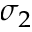<formula> <loc_0><loc_0><loc_500><loc_500>\sigma _ { 2 }</formula> 